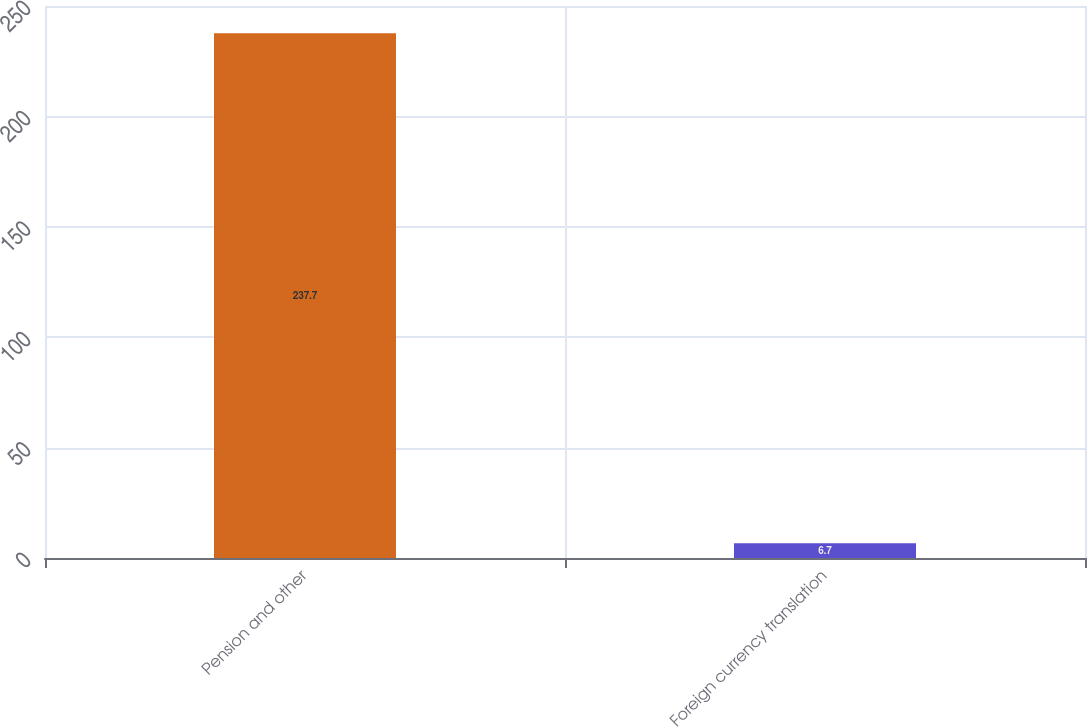<chart> <loc_0><loc_0><loc_500><loc_500><bar_chart><fcel>Pension and other<fcel>Foreign currency translation<nl><fcel>237.7<fcel>6.7<nl></chart> 